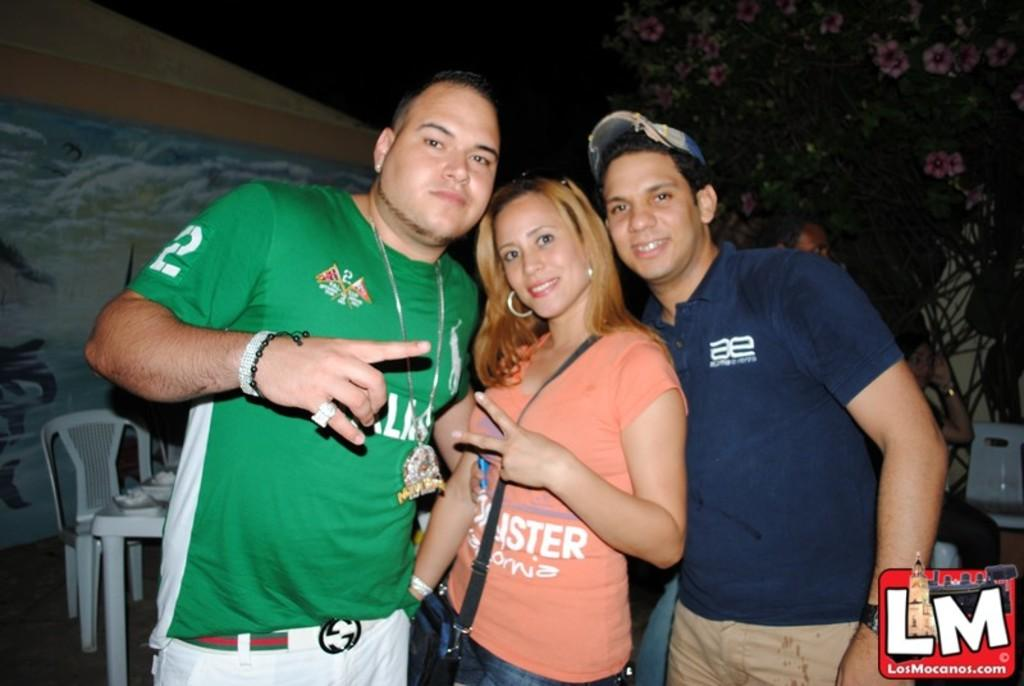How many people are in the image? There are three persons in the image. What are the three persons doing? The three persons are standing and smiling. Can you describe the attire of the persons? One person is wearing a bag, and another person is wearing a cap. What can be seen in the background of the image? There is a wall, chairs, a table, other persons, and a tree with flowers in the background of the image. What type of doll can be seen on the bed in the image? There is no doll or bed present in the image. Can you hear thunder in the background of the image? There is no mention of thunder or any sound in the image, so it cannot be determined from the picture. 